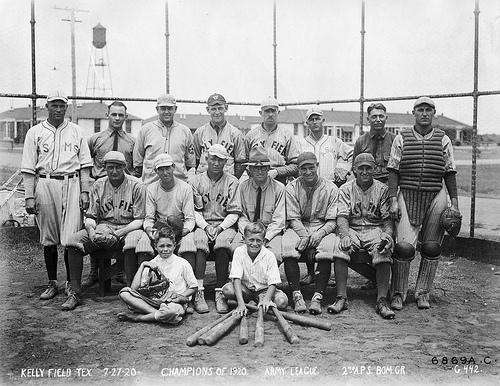How many boys?
Give a very brief answer. 2. 